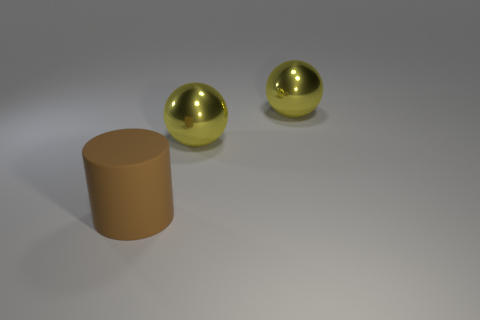Are there any large yellow objects?
Ensure brevity in your answer.  Yes. What number of big things are either gray metallic balls or rubber things?
Keep it short and to the point. 1. There is a rubber cylinder; how many brown matte cylinders are behind it?
Your answer should be very brief. 0. Is there a big yellow ball made of the same material as the large cylinder?
Provide a short and direct response. No. What number of objects are either large objects or things on the right side of the brown cylinder?
Provide a succinct answer. 3. Are there more large cylinders that are on the right side of the brown cylinder than large things?
Your response must be concise. No. Is there anything else that has the same color as the matte object?
Your answer should be compact. No. Are there any other things that have the same material as the cylinder?
Ensure brevity in your answer.  No. What material is the brown thing?
Your answer should be very brief. Rubber. What number of other objects are the same shape as the big brown object?
Offer a terse response. 0. 